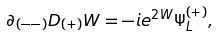Convert formula to latex. <formula><loc_0><loc_0><loc_500><loc_500>\partial _ { ( - - ) } D _ { ( + ) } W = - i e ^ { 2 W } \Psi _ { L } ^ { ( + ) } ,</formula> 